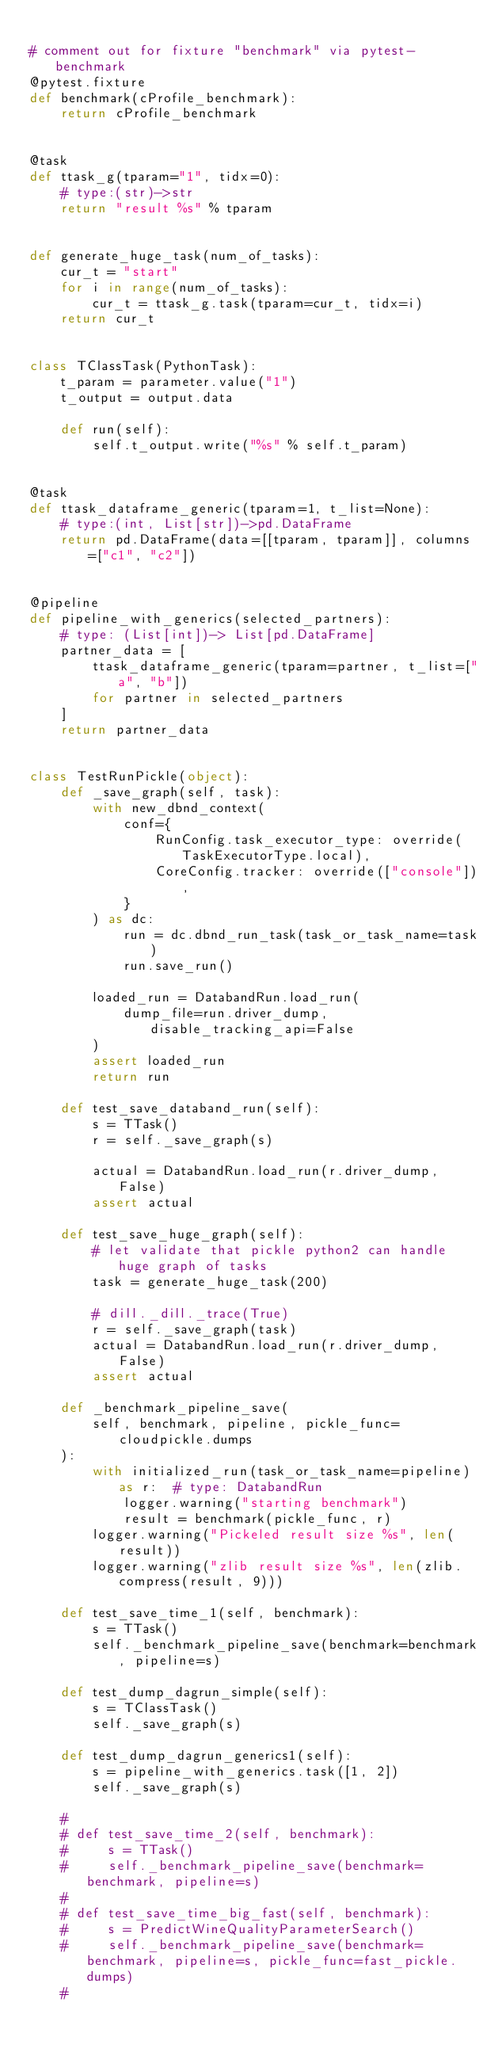Convert code to text. <code><loc_0><loc_0><loc_500><loc_500><_Python_>
# comment out for fixture "benchmark" via pytest-benchmark
@pytest.fixture
def benchmark(cProfile_benchmark):
    return cProfile_benchmark


@task
def ttask_g(tparam="1", tidx=0):
    # type:(str)->str
    return "result %s" % tparam


def generate_huge_task(num_of_tasks):
    cur_t = "start"
    for i in range(num_of_tasks):
        cur_t = ttask_g.task(tparam=cur_t, tidx=i)
    return cur_t


class TClassTask(PythonTask):
    t_param = parameter.value("1")
    t_output = output.data

    def run(self):
        self.t_output.write("%s" % self.t_param)


@task
def ttask_dataframe_generic(tparam=1, t_list=None):
    # type:(int, List[str])->pd.DataFrame
    return pd.DataFrame(data=[[tparam, tparam]], columns=["c1", "c2"])


@pipeline
def pipeline_with_generics(selected_partners):
    # type: (List[int])-> List[pd.DataFrame]
    partner_data = [
        ttask_dataframe_generic(tparam=partner, t_list=["a", "b"])
        for partner in selected_partners
    ]
    return partner_data


class TestRunPickle(object):
    def _save_graph(self, task):
        with new_dbnd_context(
            conf={
                RunConfig.task_executor_type: override(TaskExecutorType.local),
                CoreConfig.tracker: override(["console"]),
            }
        ) as dc:
            run = dc.dbnd_run_task(task_or_task_name=task)
            run.save_run()

        loaded_run = DatabandRun.load_run(
            dump_file=run.driver_dump, disable_tracking_api=False
        )
        assert loaded_run
        return run

    def test_save_databand_run(self):
        s = TTask()
        r = self._save_graph(s)

        actual = DatabandRun.load_run(r.driver_dump, False)
        assert actual

    def test_save_huge_graph(self):
        # let validate that pickle python2 can handle huge graph of tasks
        task = generate_huge_task(200)

        # dill._dill._trace(True)
        r = self._save_graph(task)
        actual = DatabandRun.load_run(r.driver_dump, False)
        assert actual

    def _benchmark_pipeline_save(
        self, benchmark, pipeline, pickle_func=cloudpickle.dumps
    ):
        with initialized_run(task_or_task_name=pipeline) as r:  # type: DatabandRun
            logger.warning("starting benchmark")
            result = benchmark(pickle_func, r)
        logger.warning("Pickeled result size %s", len(result))
        logger.warning("zlib result size %s", len(zlib.compress(result, 9)))

    def test_save_time_1(self, benchmark):
        s = TTask()
        self._benchmark_pipeline_save(benchmark=benchmark, pipeline=s)

    def test_dump_dagrun_simple(self):
        s = TClassTask()
        self._save_graph(s)

    def test_dump_dagrun_generics1(self):
        s = pipeline_with_generics.task([1, 2])
        self._save_graph(s)

    #
    # def test_save_time_2(self, benchmark):
    #     s = TTask()
    #     self._benchmark_pipeline_save(benchmark=benchmark, pipeline=s)
    #
    # def test_save_time_big_fast(self, benchmark):
    #     s = PredictWineQualityParameterSearch()
    #     self._benchmark_pipeline_save(benchmark=benchmark, pipeline=s, pickle_func=fast_pickle.dumps)
    #</code> 